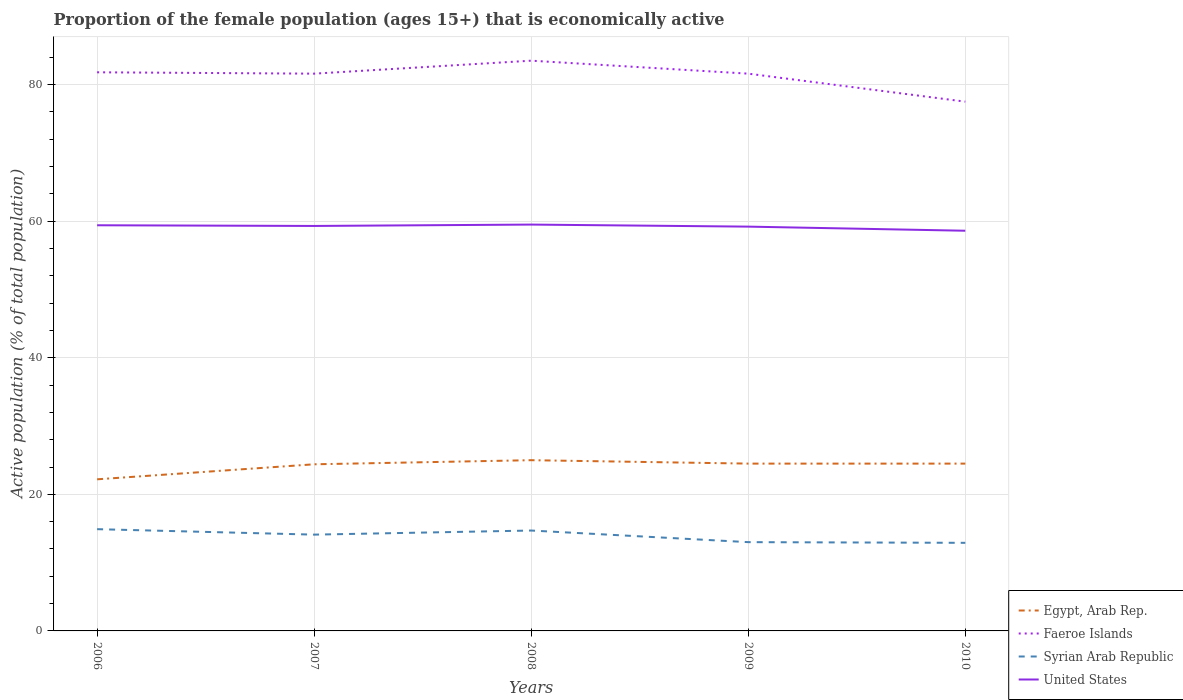Is the number of lines equal to the number of legend labels?
Provide a short and direct response. Yes. Across all years, what is the maximum proportion of the female population that is economically active in Faeroe Islands?
Offer a terse response. 77.5. In which year was the proportion of the female population that is economically active in United States maximum?
Your answer should be compact. 2010. What is the total proportion of the female population that is economically active in United States in the graph?
Your answer should be very brief. 0.1. What is the difference between the highest and the second highest proportion of the female population that is economically active in Egypt, Arab Rep.?
Your answer should be very brief. 2.8. What is the difference between the highest and the lowest proportion of the female population that is economically active in Faeroe Islands?
Ensure brevity in your answer.  4. How many lines are there?
Ensure brevity in your answer.  4. What is the difference between two consecutive major ticks on the Y-axis?
Provide a succinct answer. 20. Does the graph contain any zero values?
Provide a short and direct response. No. Does the graph contain grids?
Your answer should be compact. Yes. Where does the legend appear in the graph?
Your response must be concise. Bottom right. How many legend labels are there?
Keep it short and to the point. 4. What is the title of the graph?
Ensure brevity in your answer.  Proportion of the female population (ages 15+) that is economically active. What is the label or title of the X-axis?
Ensure brevity in your answer.  Years. What is the label or title of the Y-axis?
Ensure brevity in your answer.  Active population (% of total population). What is the Active population (% of total population) in Egypt, Arab Rep. in 2006?
Offer a terse response. 22.2. What is the Active population (% of total population) in Faeroe Islands in 2006?
Make the answer very short. 81.8. What is the Active population (% of total population) of Syrian Arab Republic in 2006?
Ensure brevity in your answer.  14.9. What is the Active population (% of total population) of United States in 2006?
Offer a very short reply. 59.4. What is the Active population (% of total population) in Egypt, Arab Rep. in 2007?
Provide a short and direct response. 24.4. What is the Active population (% of total population) in Faeroe Islands in 2007?
Offer a very short reply. 81.6. What is the Active population (% of total population) of Syrian Arab Republic in 2007?
Offer a terse response. 14.1. What is the Active population (% of total population) of United States in 2007?
Make the answer very short. 59.3. What is the Active population (% of total population) in Faeroe Islands in 2008?
Provide a succinct answer. 83.5. What is the Active population (% of total population) in Syrian Arab Republic in 2008?
Keep it short and to the point. 14.7. What is the Active population (% of total population) of United States in 2008?
Make the answer very short. 59.5. What is the Active population (% of total population) of Egypt, Arab Rep. in 2009?
Provide a succinct answer. 24.5. What is the Active population (% of total population) of Faeroe Islands in 2009?
Offer a terse response. 81.6. What is the Active population (% of total population) in United States in 2009?
Provide a short and direct response. 59.2. What is the Active population (% of total population) of Egypt, Arab Rep. in 2010?
Ensure brevity in your answer.  24.5. What is the Active population (% of total population) of Faeroe Islands in 2010?
Your answer should be compact. 77.5. What is the Active population (% of total population) in Syrian Arab Republic in 2010?
Offer a terse response. 12.9. What is the Active population (% of total population) in United States in 2010?
Make the answer very short. 58.6. Across all years, what is the maximum Active population (% of total population) of Egypt, Arab Rep.?
Your response must be concise. 25. Across all years, what is the maximum Active population (% of total population) of Faeroe Islands?
Your answer should be very brief. 83.5. Across all years, what is the maximum Active population (% of total population) in Syrian Arab Republic?
Offer a terse response. 14.9. Across all years, what is the maximum Active population (% of total population) of United States?
Make the answer very short. 59.5. Across all years, what is the minimum Active population (% of total population) of Egypt, Arab Rep.?
Provide a short and direct response. 22.2. Across all years, what is the minimum Active population (% of total population) of Faeroe Islands?
Provide a succinct answer. 77.5. Across all years, what is the minimum Active population (% of total population) in Syrian Arab Republic?
Make the answer very short. 12.9. Across all years, what is the minimum Active population (% of total population) in United States?
Provide a short and direct response. 58.6. What is the total Active population (% of total population) of Egypt, Arab Rep. in the graph?
Offer a terse response. 120.6. What is the total Active population (% of total population) of Faeroe Islands in the graph?
Keep it short and to the point. 406. What is the total Active population (% of total population) in Syrian Arab Republic in the graph?
Provide a succinct answer. 69.6. What is the total Active population (% of total population) of United States in the graph?
Make the answer very short. 296. What is the difference between the Active population (% of total population) in Egypt, Arab Rep. in 2006 and that in 2007?
Offer a very short reply. -2.2. What is the difference between the Active population (% of total population) of Faeroe Islands in 2006 and that in 2007?
Provide a succinct answer. 0.2. What is the difference between the Active population (% of total population) in Syrian Arab Republic in 2006 and that in 2007?
Provide a short and direct response. 0.8. What is the difference between the Active population (% of total population) in United States in 2006 and that in 2007?
Your answer should be compact. 0.1. What is the difference between the Active population (% of total population) of Egypt, Arab Rep. in 2006 and that in 2008?
Ensure brevity in your answer.  -2.8. What is the difference between the Active population (% of total population) of Syrian Arab Republic in 2006 and that in 2008?
Keep it short and to the point. 0.2. What is the difference between the Active population (% of total population) of Egypt, Arab Rep. in 2006 and that in 2009?
Keep it short and to the point. -2.3. What is the difference between the Active population (% of total population) of Faeroe Islands in 2006 and that in 2009?
Make the answer very short. 0.2. What is the difference between the Active population (% of total population) of Syrian Arab Republic in 2006 and that in 2009?
Provide a short and direct response. 1.9. What is the difference between the Active population (% of total population) of United States in 2006 and that in 2009?
Your answer should be very brief. 0.2. What is the difference between the Active population (% of total population) of Egypt, Arab Rep. in 2006 and that in 2010?
Provide a short and direct response. -2.3. What is the difference between the Active population (% of total population) of Faeroe Islands in 2007 and that in 2008?
Keep it short and to the point. -1.9. What is the difference between the Active population (% of total population) of Syrian Arab Republic in 2007 and that in 2008?
Ensure brevity in your answer.  -0.6. What is the difference between the Active population (% of total population) of United States in 2007 and that in 2008?
Offer a very short reply. -0.2. What is the difference between the Active population (% of total population) of Faeroe Islands in 2007 and that in 2009?
Your answer should be very brief. 0. What is the difference between the Active population (% of total population) in Egypt, Arab Rep. in 2007 and that in 2010?
Ensure brevity in your answer.  -0.1. What is the difference between the Active population (% of total population) of Faeroe Islands in 2007 and that in 2010?
Provide a short and direct response. 4.1. What is the difference between the Active population (% of total population) in United States in 2007 and that in 2010?
Your answer should be compact. 0.7. What is the difference between the Active population (% of total population) in Egypt, Arab Rep. in 2008 and that in 2009?
Provide a succinct answer. 0.5. What is the difference between the Active population (% of total population) in United States in 2008 and that in 2009?
Ensure brevity in your answer.  0.3. What is the difference between the Active population (% of total population) of Syrian Arab Republic in 2008 and that in 2010?
Provide a short and direct response. 1.8. What is the difference between the Active population (% of total population) of United States in 2008 and that in 2010?
Ensure brevity in your answer.  0.9. What is the difference between the Active population (% of total population) in Egypt, Arab Rep. in 2009 and that in 2010?
Provide a succinct answer. 0. What is the difference between the Active population (% of total population) of United States in 2009 and that in 2010?
Provide a succinct answer. 0.6. What is the difference between the Active population (% of total population) of Egypt, Arab Rep. in 2006 and the Active population (% of total population) of Faeroe Islands in 2007?
Ensure brevity in your answer.  -59.4. What is the difference between the Active population (% of total population) of Egypt, Arab Rep. in 2006 and the Active population (% of total population) of Syrian Arab Republic in 2007?
Make the answer very short. 8.1. What is the difference between the Active population (% of total population) in Egypt, Arab Rep. in 2006 and the Active population (% of total population) in United States in 2007?
Your response must be concise. -37.1. What is the difference between the Active population (% of total population) of Faeroe Islands in 2006 and the Active population (% of total population) of Syrian Arab Republic in 2007?
Offer a terse response. 67.7. What is the difference between the Active population (% of total population) in Faeroe Islands in 2006 and the Active population (% of total population) in United States in 2007?
Make the answer very short. 22.5. What is the difference between the Active population (% of total population) in Syrian Arab Republic in 2006 and the Active population (% of total population) in United States in 2007?
Provide a short and direct response. -44.4. What is the difference between the Active population (% of total population) in Egypt, Arab Rep. in 2006 and the Active population (% of total population) in Faeroe Islands in 2008?
Provide a short and direct response. -61.3. What is the difference between the Active population (% of total population) of Egypt, Arab Rep. in 2006 and the Active population (% of total population) of Syrian Arab Republic in 2008?
Provide a short and direct response. 7.5. What is the difference between the Active population (% of total population) of Egypt, Arab Rep. in 2006 and the Active population (% of total population) of United States in 2008?
Keep it short and to the point. -37.3. What is the difference between the Active population (% of total population) in Faeroe Islands in 2006 and the Active population (% of total population) in Syrian Arab Republic in 2008?
Your answer should be very brief. 67.1. What is the difference between the Active population (% of total population) of Faeroe Islands in 2006 and the Active population (% of total population) of United States in 2008?
Provide a short and direct response. 22.3. What is the difference between the Active population (% of total population) of Syrian Arab Republic in 2006 and the Active population (% of total population) of United States in 2008?
Your response must be concise. -44.6. What is the difference between the Active population (% of total population) in Egypt, Arab Rep. in 2006 and the Active population (% of total population) in Faeroe Islands in 2009?
Offer a terse response. -59.4. What is the difference between the Active population (% of total population) of Egypt, Arab Rep. in 2006 and the Active population (% of total population) of Syrian Arab Republic in 2009?
Give a very brief answer. 9.2. What is the difference between the Active population (% of total population) in Egypt, Arab Rep. in 2006 and the Active population (% of total population) in United States in 2009?
Give a very brief answer. -37. What is the difference between the Active population (% of total population) of Faeroe Islands in 2006 and the Active population (% of total population) of Syrian Arab Republic in 2009?
Give a very brief answer. 68.8. What is the difference between the Active population (% of total population) of Faeroe Islands in 2006 and the Active population (% of total population) of United States in 2009?
Your answer should be very brief. 22.6. What is the difference between the Active population (% of total population) of Syrian Arab Republic in 2006 and the Active population (% of total population) of United States in 2009?
Provide a succinct answer. -44.3. What is the difference between the Active population (% of total population) of Egypt, Arab Rep. in 2006 and the Active population (% of total population) of Faeroe Islands in 2010?
Make the answer very short. -55.3. What is the difference between the Active population (% of total population) of Egypt, Arab Rep. in 2006 and the Active population (% of total population) of Syrian Arab Republic in 2010?
Your answer should be compact. 9.3. What is the difference between the Active population (% of total population) in Egypt, Arab Rep. in 2006 and the Active population (% of total population) in United States in 2010?
Offer a very short reply. -36.4. What is the difference between the Active population (% of total population) of Faeroe Islands in 2006 and the Active population (% of total population) of Syrian Arab Republic in 2010?
Your answer should be compact. 68.9. What is the difference between the Active population (% of total population) of Faeroe Islands in 2006 and the Active population (% of total population) of United States in 2010?
Offer a very short reply. 23.2. What is the difference between the Active population (% of total population) of Syrian Arab Republic in 2006 and the Active population (% of total population) of United States in 2010?
Give a very brief answer. -43.7. What is the difference between the Active population (% of total population) of Egypt, Arab Rep. in 2007 and the Active population (% of total population) of Faeroe Islands in 2008?
Give a very brief answer. -59.1. What is the difference between the Active population (% of total population) in Egypt, Arab Rep. in 2007 and the Active population (% of total population) in United States in 2008?
Make the answer very short. -35.1. What is the difference between the Active population (% of total population) of Faeroe Islands in 2007 and the Active population (% of total population) of Syrian Arab Republic in 2008?
Your answer should be compact. 66.9. What is the difference between the Active population (% of total population) of Faeroe Islands in 2007 and the Active population (% of total population) of United States in 2008?
Ensure brevity in your answer.  22.1. What is the difference between the Active population (% of total population) in Syrian Arab Republic in 2007 and the Active population (% of total population) in United States in 2008?
Keep it short and to the point. -45.4. What is the difference between the Active population (% of total population) of Egypt, Arab Rep. in 2007 and the Active population (% of total population) of Faeroe Islands in 2009?
Keep it short and to the point. -57.2. What is the difference between the Active population (% of total population) of Egypt, Arab Rep. in 2007 and the Active population (% of total population) of United States in 2009?
Offer a terse response. -34.8. What is the difference between the Active population (% of total population) of Faeroe Islands in 2007 and the Active population (% of total population) of Syrian Arab Republic in 2009?
Your response must be concise. 68.6. What is the difference between the Active population (% of total population) in Faeroe Islands in 2007 and the Active population (% of total population) in United States in 2009?
Your answer should be compact. 22.4. What is the difference between the Active population (% of total population) in Syrian Arab Republic in 2007 and the Active population (% of total population) in United States in 2009?
Keep it short and to the point. -45.1. What is the difference between the Active population (% of total population) of Egypt, Arab Rep. in 2007 and the Active population (% of total population) of Faeroe Islands in 2010?
Offer a terse response. -53.1. What is the difference between the Active population (% of total population) in Egypt, Arab Rep. in 2007 and the Active population (% of total population) in United States in 2010?
Provide a succinct answer. -34.2. What is the difference between the Active population (% of total population) of Faeroe Islands in 2007 and the Active population (% of total population) of Syrian Arab Republic in 2010?
Your answer should be compact. 68.7. What is the difference between the Active population (% of total population) of Syrian Arab Republic in 2007 and the Active population (% of total population) of United States in 2010?
Your response must be concise. -44.5. What is the difference between the Active population (% of total population) in Egypt, Arab Rep. in 2008 and the Active population (% of total population) in Faeroe Islands in 2009?
Your response must be concise. -56.6. What is the difference between the Active population (% of total population) in Egypt, Arab Rep. in 2008 and the Active population (% of total population) in Syrian Arab Republic in 2009?
Your answer should be very brief. 12. What is the difference between the Active population (% of total population) of Egypt, Arab Rep. in 2008 and the Active population (% of total population) of United States in 2009?
Provide a succinct answer. -34.2. What is the difference between the Active population (% of total population) in Faeroe Islands in 2008 and the Active population (% of total population) in Syrian Arab Republic in 2009?
Your response must be concise. 70.5. What is the difference between the Active population (% of total population) of Faeroe Islands in 2008 and the Active population (% of total population) of United States in 2009?
Provide a succinct answer. 24.3. What is the difference between the Active population (% of total population) of Syrian Arab Republic in 2008 and the Active population (% of total population) of United States in 2009?
Give a very brief answer. -44.5. What is the difference between the Active population (% of total population) of Egypt, Arab Rep. in 2008 and the Active population (% of total population) of Faeroe Islands in 2010?
Provide a short and direct response. -52.5. What is the difference between the Active population (% of total population) in Egypt, Arab Rep. in 2008 and the Active population (% of total population) in Syrian Arab Republic in 2010?
Your answer should be compact. 12.1. What is the difference between the Active population (% of total population) of Egypt, Arab Rep. in 2008 and the Active population (% of total population) of United States in 2010?
Offer a terse response. -33.6. What is the difference between the Active population (% of total population) of Faeroe Islands in 2008 and the Active population (% of total population) of Syrian Arab Republic in 2010?
Make the answer very short. 70.6. What is the difference between the Active population (% of total population) of Faeroe Islands in 2008 and the Active population (% of total population) of United States in 2010?
Your response must be concise. 24.9. What is the difference between the Active population (% of total population) of Syrian Arab Republic in 2008 and the Active population (% of total population) of United States in 2010?
Offer a very short reply. -43.9. What is the difference between the Active population (% of total population) of Egypt, Arab Rep. in 2009 and the Active population (% of total population) of Faeroe Islands in 2010?
Offer a very short reply. -53. What is the difference between the Active population (% of total population) in Egypt, Arab Rep. in 2009 and the Active population (% of total population) in Syrian Arab Republic in 2010?
Offer a terse response. 11.6. What is the difference between the Active population (% of total population) of Egypt, Arab Rep. in 2009 and the Active population (% of total population) of United States in 2010?
Offer a terse response. -34.1. What is the difference between the Active population (% of total population) in Faeroe Islands in 2009 and the Active population (% of total population) in Syrian Arab Republic in 2010?
Give a very brief answer. 68.7. What is the difference between the Active population (% of total population) of Faeroe Islands in 2009 and the Active population (% of total population) of United States in 2010?
Your answer should be compact. 23. What is the difference between the Active population (% of total population) of Syrian Arab Republic in 2009 and the Active population (% of total population) of United States in 2010?
Offer a terse response. -45.6. What is the average Active population (% of total population) of Egypt, Arab Rep. per year?
Your answer should be very brief. 24.12. What is the average Active population (% of total population) in Faeroe Islands per year?
Offer a very short reply. 81.2. What is the average Active population (% of total population) of Syrian Arab Republic per year?
Make the answer very short. 13.92. What is the average Active population (% of total population) in United States per year?
Make the answer very short. 59.2. In the year 2006, what is the difference between the Active population (% of total population) of Egypt, Arab Rep. and Active population (% of total population) of Faeroe Islands?
Your answer should be compact. -59.6. In the year 2006, what is the difference between the Active population (% of total population) in Egypt, Arab Rep. and Active population (% of total population) in Syrian Arab Republic?
Offer a terse response. 7.3. In the year 2006, what is the difference between the Active population (% of total population) in Egypt, Arab Rep. and Active population (% of total population) in United States?
Ensure brevity in your answer.  -37.2. In the year 2006, what is the difference between the Active population (% of total population) in Faeroe Islands and Active population (% of total population) in Syrian Arab Republic?
Your response must be concise. 66.9. In the year 2006, what is the difference between the Active population (% of total population) in Faeroe Islands and Active population (% of total population) in United States?
Offer a very short reply. 22.4. In the year 2006, what is the difference between the Active population (% of total population) in Syrian Arab Republic and Active population (% of total population) in United States?
Provide a succinct answer. -44.5. In the year 2007, what is the difference between the Active population (% of total population) in Egypt, Arab Rep. and Active population (% of total population) in Faeroe Islands?
Your answer should be compact. -57.2. In the year 2007, what is the difference between the Active population (% of total population) in Egypt, Arab Rep. and Active population (% of total population) in United States?
Your answer should be compact. -34.9. In the year 2007, what is the difference between the Active population (% of total population) in Faeroe Islands and Active population (% of total population) in Syrian Arab Republic?
Offer a very short reply. 67.5. In the year 2007, what is the difference between the Active population (% of total population) of Faeroe Islands and Active population (% of total population) of United States?
Provide a short and direct response. 22.3. In the year 2007, what is the difference between the Active population (% of total population) of Syrian Arab Republic and Active population (% of total population) of United States?
Your response must be concise. -45.2. In the year 2008, what is the difference between the Active population (% of total population) of Egypt, Arab Rep. and Active population (% of total population) of Faeroe Islands?
Your answer should be very brief. -58.5. In the year 2008, what is the difference between the Active population (% of total population) in Egypt, Arab Rep. and Active population (% of total population) in United States?
Ensure brevity in your answer.  -34.5. In the year 2008, what is the difference between the Active population (% of total population) in Faeroe Islands and Active population (% of total population) in Syrian Arab Republic?
Your answer should be compact. 68.8. In the year 2008, what is the difference between the Active population (% of total population) in Faeroe Islands and Active population (% of total population) in United States?
Ensure brevity in your answer.  24. In the year 2008, what is the difference between the Active population (% of total population) of Syrian Arab Republic and Active population (% of total population) of United States?
Ensure brevity in your answer.  -44.8. In the year 2009, what is the difference between the Active population (% of total population) of Egypt, Arab Rep. and Active population (% of total population) of Faeroe Islands?
Ensure brevity in your answer.  -57.1. In the year 2009, what is the difference between the Active population (% of total population) of Egypt, Arab Rep. and Active population (% of total population) of Syrian Arab Republic?
Keep it short and to the point. 11.5. In the year 2009, what is the difference between the Active population (% of total population) in Egypt, Arab Rep. and Active population (% of total population) in United States?
Your response must be concise. -34.7. In the year 2009, what is the difference between the Active population (% of total population) in Faeroe Islands and Active population (% of total population) in Syrian Arab Republic?
Offer a very short reply. 68.6. In the year 2009, what is the difference between the Active population (% of total population) in Faeroe Islands and Active population (% of total population) in United States?
Your answer should be compact. 22.4. In the year 2009, what is the difference between the Active population (% of total population) in Syrian Arab Republic and Active population (% of total population) in United States?
Give a very brief answer. -46.2. In the year 2010, what is the difference between the Active population (% of total population) in Egypt, Arab Rep. and Active population (% of total population) in Faeroe Islands?
Your answer should be compact. -53. In the year 2010, what is the difference between the Active population (% of total population) in Egypt, Arab Rep. and Active population (% of total population) in United States?
Ensure brevity in your answer.  -34.1. In the year 2010, what is the difference between the Active population (% of total population) in Faeroe Islands and Active population (% of total population) in Syrian Arab Republic?
Offer a very short reply. 64.6. In the year 2010, what is the difference between the Active population (% of total population) of Faeroe Islands and Active population (% of total population) of United States?
Provide a succinct answer. 18.9. In the year 2010, what is the difference between the Active population (% of total population) in Syrian Arab Republic and Active population (% of total population) in United States?
Offer a terse response. -45.7. What is the ratio of the Active population (% of total population) in Egypt, Arab Rep. in 2006 to that in 2007?
Offer a terse response. 0.91. What is the ratio of the Active population (% of total population) of Syrian Arab Republic in 2006 to that in 2007?
Offer a terse response. 1.06. What is the ratio of the Active population (% of total population) in Egypt, Arab Rep. in 2006 to that in 2008?
Offer a terse response. 0.89. What is the ratio of the Active population (% of total population) of Faeroe Islands in 2006 to that in 2008?
Keep it short and to the point. 0.98. What is the ratio of the Active population (% of total population) in Syrian Arab Republic in 2006 to that in 2008?
Keep it short and to the point. 1.01. What is the ratio of the Active population (% of total population) in Egypt, Arab Rep. in 2006 to that in 2009?
Offer a terse response. 0.91. What is the ratio of the Active population (% of total population) in Syrian Arab Republic in 2006 to that in 2009?
Give a very brief answer. 1.15. What is the ratio of the Active population (% of total population) of Egypt, Arab Rep. in 2006 to that in 2010?
Make the answer very short. 0.91. What is the ratio of the Active population (% of total population) of Faeroe Islands in 2006 to that in 2010?
Provide a short and direct response. 1.06. What is the ratio of the Active population (% of total population) in Syrian Arab Republic in 2006 to that in 2010?
Offer a very short reply. 1.16. What is the ratio of the Active population (% of total population) in United States in 2006 to that in 2010?
Offer a terse response. 1.01. What is the ratio of the Active population (% of total population) in Faeroe Islands in 2007 to that in 2008?
Your response must be concise. 0.98. What is the ratio of the Active population (% of total population) of Syrian Arab Republic in 2007 to that in 2008?
Ensure brevity in your answer.  0.96. What is the ratio of the Active population (% of total population) of Egypt, Arab Rep. in 2007 to that in 2009?
Make the answer very short. 1. What is the ratio of the Active population (% of total population) in Syrian Arab Republic in 2007 to that in 2009?
Provide a succinct answer. 1.08. What is the ratio of the Active population (% of total population) in Faeroe Islands in 2007 to that in 2010?
Provide a succinct answer. 1.05. What is the ratio of the Active population (% of total population) of Syrian Arab Republic in 2007 to that in 2010?
Keep it short and to the point. 1.09. What is the ratio of the Active population (% of total population) in United States in 2007 to that in 2010?
Keep it short and to the point. 1.01. What is the ratio of the Active population (% of total population) in Egypt, Arab Rep. in 2008 to that in 2009?
Offer a very short reply. 1.02. What is the ratio of the Active population (% of total population) of Faeroe Islands in 2008 to that in 2009?
Provide a short and direct response. 1.02. What is the ratio of the Active population (% of total population) in Syrian Arab Republic in 2008 to that in 2009?
Give a very brief answer. 1.13. What is the ratio of the Active population (% of total population) of Egypt, Arab Rep. in 2008 to that in 2010?
Offer a terse response. 1.02. What is the ratio of the Active population (% of total population) of Faeroe Islands in 2008 to that in 2010?
Ensure brevity in your answer.  1.08. What is the ratio of the Active population (% of total population) of Syrian Arab Republic in 2008 to that in 2010?
Provide a succinct answer. 1.14. What is the ratio of the Active population (% of total population) of United States in 2008 to that in 2010?
Your answer should be compact. 1.02. What is the ratio of the Active population (% of total population) of Egypt, Arab Rep. in 2009 to that in 2010?
Your response must be concise. 1. What is the ratio of the Active population (% of total population) in Faeroe Islands in 2009 to that in 2010?
Keep it short and to the point. 1.05. What is the ratio of the Active population (% of total population) of United States in 2009 to that in 2010?
Offer a very short reply. 1.01. What is the difference between the highest and the second highest Active population (% of total population) in Egypt, Arab Rep.?
Offer a terse response. 0.5. What is the difference between the highest and the lowest Active population (% of total population) of Egypt, Arab Rep.?
Give a very brief answer. 2.8. What is the difference between the highest and the lowest Active population (% of total population) in Faeroe Islands?
Your response must be concise. 6. What is the difference between the highest and the lowest Active population (% of total population) of Syrian Arab Republic?
Provide a short and direct response. 2. What is the difference between the highest and the lowest Active population (% of total population) of United States?
Provide a short and direct response. 0.9. 